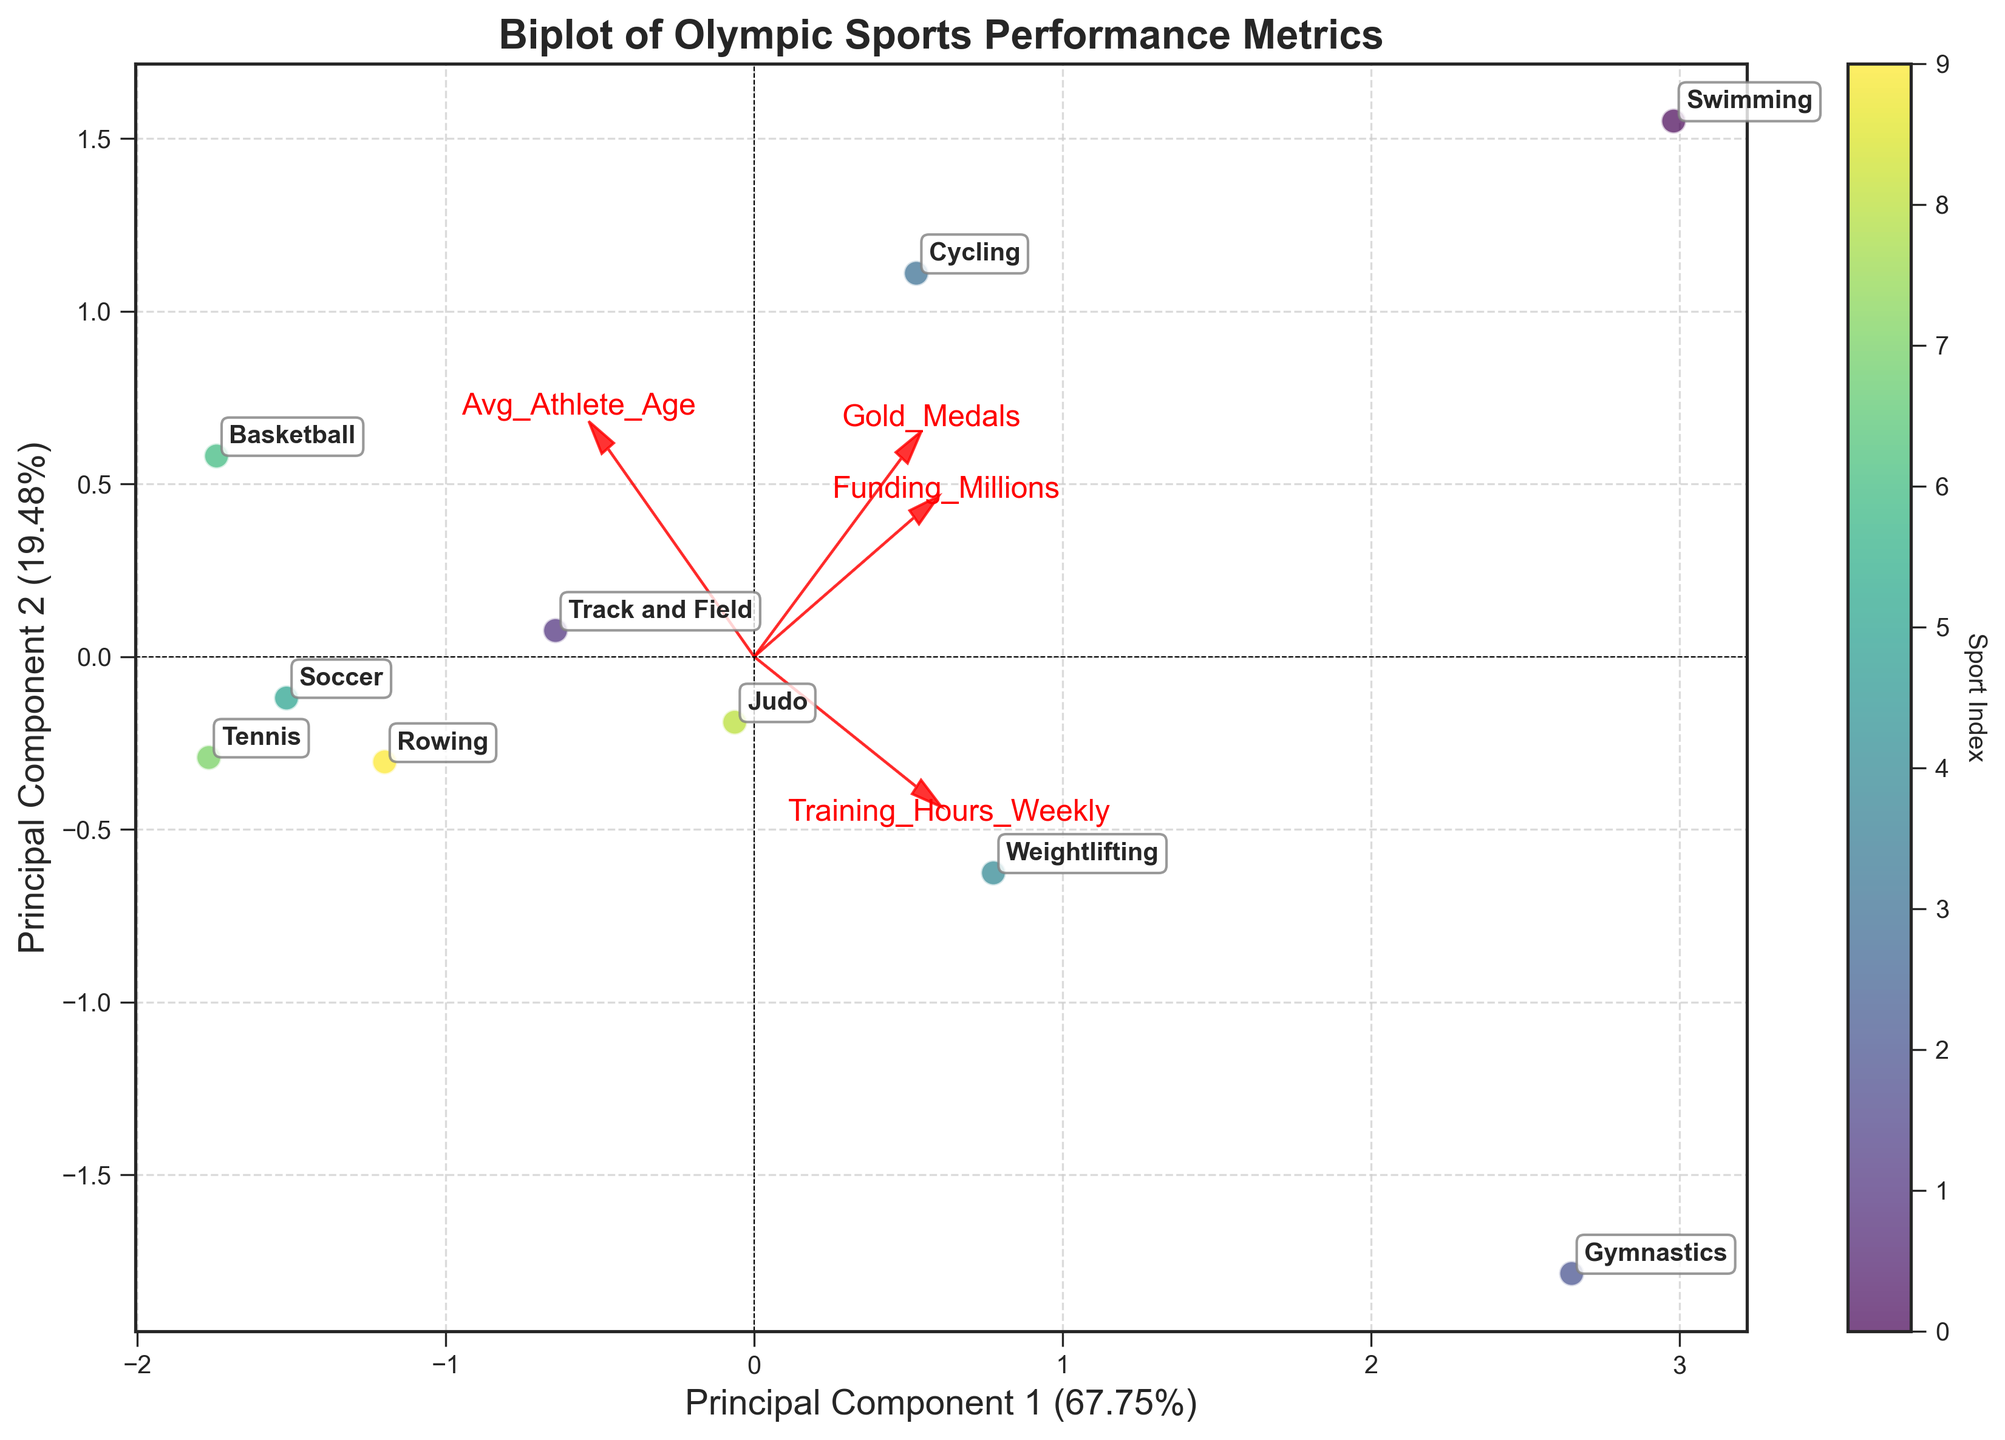What is the title of the figure? The title of a figure is usually displayed at the top and is meant to describe what the visual representation is about. In this case, you can reference the top part of the display to find the title.
Answer: Biplot of Olympic Sports Performance Metrics How many sports are represented in the biplot? Look at the different data points and their associated labels, which are annotated next to the points. Count these sports labels.
Answer: 10 Which sport has the highest funding based on the direction of the 'Funding_Millions' vector? To find this, look at the direction of the 'Funding_Millions' vector in the biplot and determine which sport's data point is furthest along this vector's direction.
Answer: USA (Swimming) What are the principal components labeled on the x and y axis respectively? Look at the labels on the x-axis and y-axis to find the names of the principal components.
Answer: Principal Component 1 and Principal Component 2 Which sport has the oldest athletes on average? Check the direction of the 'Avg_Athlete_Age' vector, and see which sport's data point is furthest in this direction.
Answer: Spain (Basketball) How many data points fall into the first quadrant (both PC1 and PC2 are positive)? Identify which quadrant is formed by positive values of both PC1 and PC2, then count the number of data points in that area.
Answer: 4 Among the sports represented, which one has the highest training hours weekly? Look at the direction of the 'Training_Hours_Weekly' vector and find which sport is furthest in that direction.
Answer: Russia (Gymnastics) How are 'Gold_Medals' and 'Funding_Millions' related based on their vectors? Examine the angles between the 'Gold_Medals' and 'Funding_Millions' vectors. If they are pointing in the same general direction, they are positively correlated.
Answer: Positively correlated Which two sports are closest in the biplot, suggesting they have similar performance metrics? Look for the two data points that are nearest to each other on the biplot.
Answer: Judo (Japan) and Rowing (New Zealand) Which sport seems to have the lowest average athlete age, and how can you tell? Determine the direction of the 'Avg_Athlete_Age' vector, and locate the sport's data point that is in the opposite direction or furthest away from this vector.
Answer: Russia (Gymnastics) 